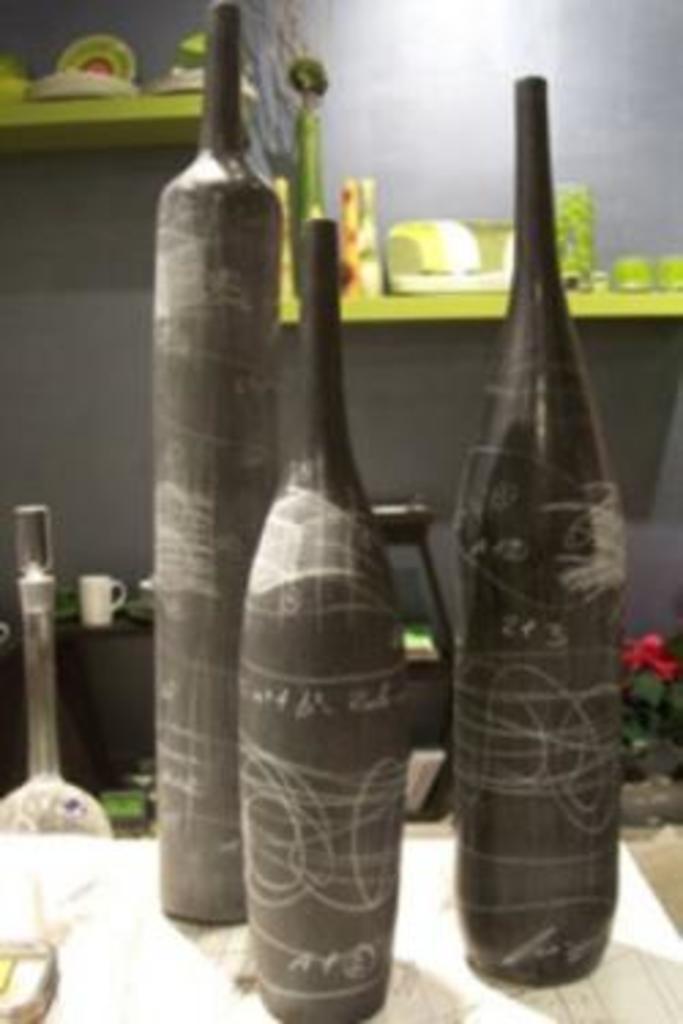Describe this image in one or two sentences. In the image there are few black bottles on a table and behind it there is shelf to the wall with bowls,cups on it and below there is a plant on the right side and table on the left side. 